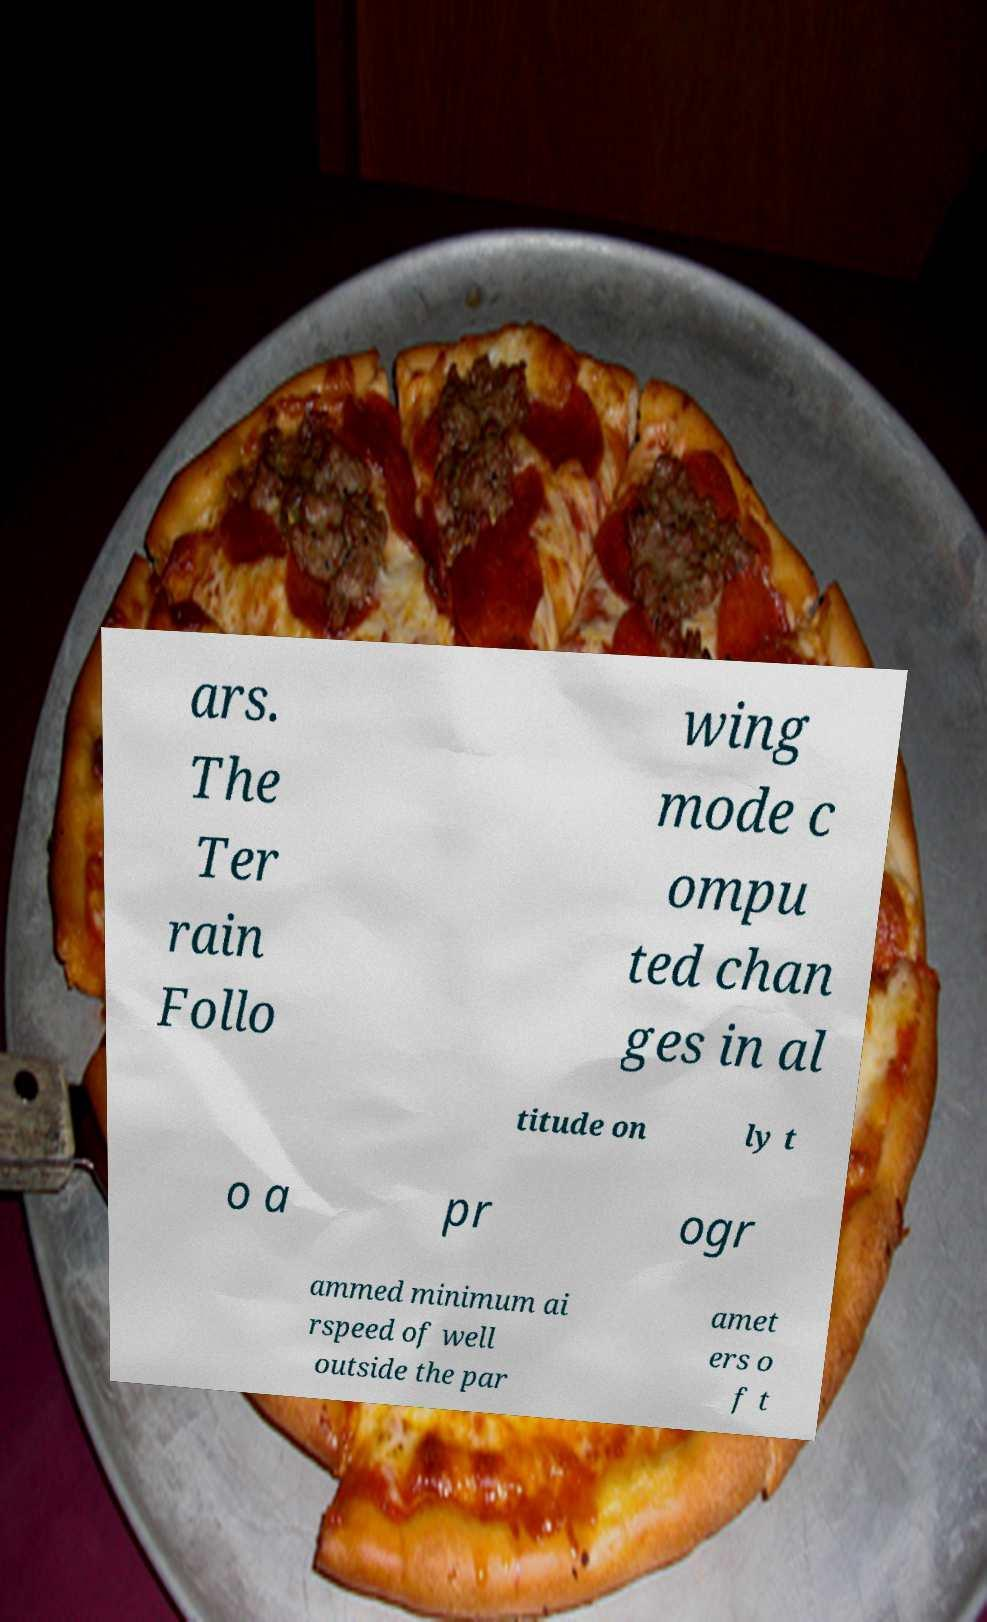What messages or text are displayed in this image? I need them in a readable, typed format. ars. The Ter rain Follo wing mode c ompu ted chan ges in al titude on ly t o a pr ogr ammed minimum ai rspeed of well outside the par amet ers o f t 